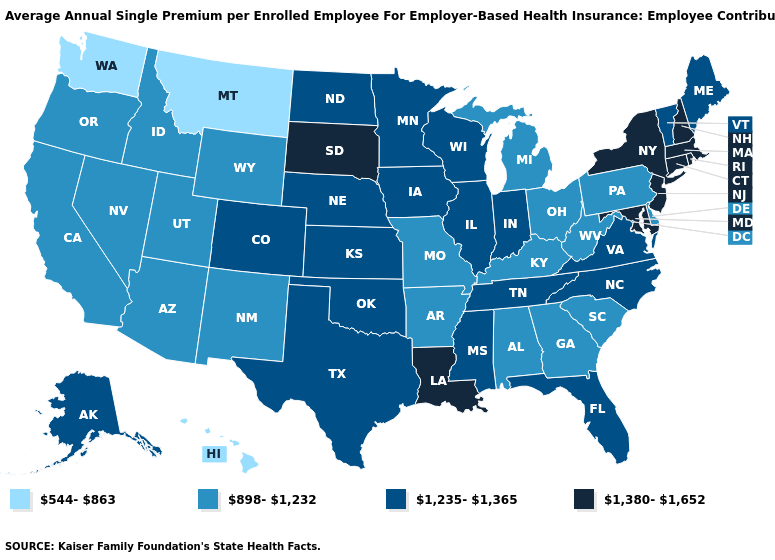Name the states that have a value in the range 1,235-1,365?
Be succinct. Alaska, Colorado, Florida, Illinois, Indiana, Iowa, Kansas, Maine, Minnesota, Mississippi, Nebraska, North Carolina, North Dakota, Oklahoma, Tennessee, Texas, Vermont, Virginia, Wisconsin. Name the states that have a value in the range 544-863?
Be succinct. Hawaii, Montana, Washington. What is the value of Michigan?
Answer briefly. 898-1,232. Name the states that have a value in the range 1,380-1,652?
Give a very brief answer. Connecticut, Louisiana, Maryland, Massachusetts, New Hampshire, New Jersey, New York, Rhode Island, South Dakota. Name the states that have a value in the range 544-863?
Answer briefly. Hawaii, Montana, Washington. Among the states that border Texas , does New Mexico have the highest value?
Concise answer only. No. What is the highest value in states that border North Dakota?
Answer briefly. 1,380-1,652. Among the states that border Alabama , does Florida have the lowest value?
Answer briefly. No. What is the lowest value in states that border New Mexico?
Short answer required. 898-1,232. Does Louisiana have a lower value than Vermont?
Write a very short answer. No. Does Oklahoma have the lowest value in the South?
Keep it brief. No. Does North Dakota have the highest value in the USA?
Give a very brief answer. No. Which states have the lowest value in the USA?
Write a very short answer. Hawaii, Montana, Washington. Does the map have missing data?
Short answer required. No. Name the states that have a value in the range 898-1,232?
Give a very brief answer. Alabama, Arizona, Arkansas, California, Delaware, Georgia, Idaho, Kentucky, Michigan, Missouri, Nevada, New Mexico, Ohio, Oregon, Pennsylvania, South Carolina, Utah, West Virginia, Wyoming. 